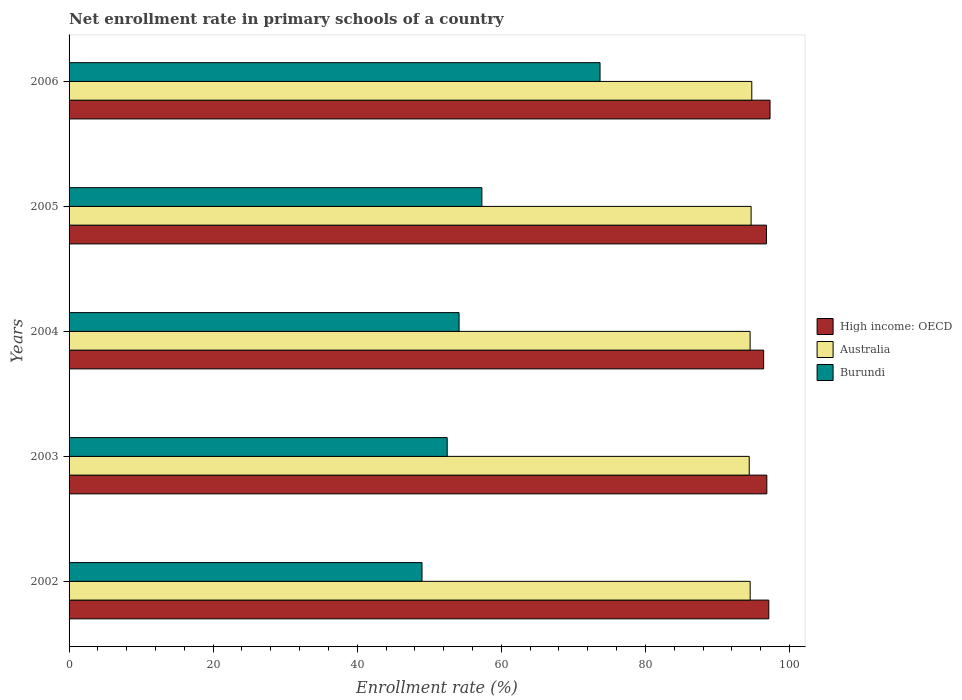How many different coloured bars are there?
Your answer should be compact. 3. Are the number of bars per tick equal to the number of legend labels?
Provide a succinct answer. Yes. How many bars are there on the 4th tick from the top?
Keep it short and to the point. 3. How many bars are there on the 5th tick from the bottom?
Your answer should be compact. 3. What is the enrollment rate in primary schools in High income: OECD in 2006?
Offer a very short reply. 97.3. Across all years, what is the maximum enrollment rate in primary schools in Australia?
Your answer should be compact. 94.77. Across all years, what is the minimum enrollment rate in primary schools in Burundi?
Keep it short and to the point. 48.99. In which year was the enrollment rate in primary schools in Burundi maximum?
Your answer should be compact. 2006. In which year was the enrollment rate in primary schools in Australia minimum?
Your answer should be compact. 2003. What is the total enrollment rate in primary schools in Burundi in the graph?
Make the answer very short. 286.64. What is the difference between the enrollment rate in primary schools in Burundi in 2003 and that in 2004?
Offer a very short reply. -1.65. What is the difference between the enrollment rate in primary schools in Burundi in 2005 and the enrollment rate in primary schools in High income: OECD in 2003?
Your response must be concise. -39.55. What is the average enrollment rate in primary schools in Burundi per year?
Give a very brief answer. 57.33. In the year 2005, what is the difference between the enrollment rate in primary schools in Burundi and enrollment rate in primary schools in Australia?
Provide a short and direct response. -37.37. What is the ratio of the enrollment rate in primary schools in High income: OECD in 2004 to that in 2006?
Keep it short and to the point. 0.99. Is the enrollment rate in primary schools in Australia in 2002 less than that in 2006?
Offer a very short reply. Yes. What is the difference between the highest and the second highest enrollment rate in primary schools in Australia?
Ensure brevity in your answer.  0.1. What is the difference between the highest and the lowest enrollment rate in primary schools in High income: OECD?
Offer a very short reply. 0.89. Is the sum of the enrollment rate in primary schools in Australia in 2002 and 2004 greater than the maximum enrollment rate in primary schools in Burundi across all years?
Your response must be concise. Yes. What does the 1st bar from the bottom in 2006 represents?
Keep it short and to the point. High income: OECD. How many bars are there?
Your answer should be compact. 15. Are the values on the major ticks of X-axis written in scientific E-notation?
Provide a short and direct response. No. Does the graph contain any zero values?
Make the answer very short. No. Where does the legend appear in the graph?
Ensure brevity in your answer.  Center right. How are the legend labels stacked?
Give a very brief answer. Vertical. What is the title of the graph?
Ensure brevity in your answer.  Net enrollment rate in primary schools of a country. What is the label or title of the X-axis?
Provide a short and direct response. Enrollment rate (%). What is the Enrollment rate (%) in High income: OECD in 2002?
Provide a succinct answer. 97.13. What is the Enrollment rate (%) of Australia in 2002?
Offer a terse response. 94.55. What is the Enrollment rate (%) of Burundi in 2002?
Give a very brief answer. 48.99. What is the Enrollment rate (%) in High income: OECD in 2003?
Give a very brief answer. 96.86. What is the Enrollment rate (%) of Australia in 2003?
Provide a short and direct response. 94.42. What is the Enrollment rate (%) in Burundi in 2003?
Ensure brevity in your answer.  52.49. What is the Enrollment rate (%) of High income: OECD in 2004?
Your answer should be compact. 96.42. What is the Enrollment rate (%) of Australia in 2004?
Make the answer very short. 94.54. What is the Enrollment rate (%) in Burundi in 2004?
Keep it short and to the point. 54.14. What is the Enrollment rate (%) in High income: OECD in 2005?
Provide a short and direct response. 96.81. What is the Enrollment rate (%) in Australia in 2005?
Provide a short and direct response. 94.68. What is the Enrollment rate (%) of Burundi in 2005?
Give a very brief answer. 57.31. What is the Enrollment rate (%) of High income: OECD in 2006?
Your response must be concise. 97.3. What is the Enrollment rate (%) of Australia in 2006?
Keep it short and to the point. 94.77. What is the Enrollment rate (%) of Burundi in 2006?
Your answer should be very brief. 73.71. Across all years, what is the maximum Enrollment rate (%) of High income: OECD?
Give a very brief answer. 97.3. Across all years, what is the maximum Enrollment rate (%) of Australia?
Provide a short and direct response. 94.77. Across all years, what is the maximum Enrollment rate (%) of Burundi?
Keep it short and to the point. 73.71. Across all years, what is the minimum Enrollment rate (%) of High income: OECD?
Your answer should be very brief. 96.42. Across all years, what is the minimum Enrollment rate (%) in Australia?
Keep it short and to the point. 94.42. Across all years, what is the minimum Enrollment rate (%) in Burundi?
Provide a short and direct response. 48.99. What is the total Enrollment rate (%) in High income: OECD in the graph?
Make the answer very short. 484.52. What is the total Enrollment rate (%) in Australia in the graph?
Offer a very short reply. 472.95. What is the total Enrollment rate (%) in Burundi in the graph?
Offer a very short reply. 286.64. What is the difference between the Enrollment rate (%) in High income: OECD in 2002 and that in 2003?
Your answer should be very brief. 0.27. What is the difference between the Enrollment rate (%) of Australia in 2002 and that in 2003?
Ensure brevity in your answer.  0.13. What is the difference between the Enrollment rate (%) in Burundi in 2002 and that in 2003?
Offer a terse response. -3.5. What is the difference between the Enrollment rate (%) of High income: OECD in 2002 and that in 2004?
Your answer should be compact. 0.71. What is the difference between the Enrollment rate (%) in Australia in 2002 and that in 2004?
Give a very brief answer. 0.01. What is the difference between the Enrollment rate (%) in Burundi in 2002 and that in 2004?
Give a very brief answer. -5.14. What is the difference between the Enrollment rate (%) of High income: OECD in 2002 and that in 2005?
Give a very brief answer. 0.33. What is the difference between the Enrollment rate (%) in Australia in 2002 and that in 2005?
Your answer should be compact. -0.13. What is the difference between the Enrollment rate (%) in Burundi in 2002 and that in 2005?
Your answer should be compact. -8.31. What is the difference between the Enrollment rate (%) in High income: OECD in 2002 and that in 2006?
Your answer should be compact. -0.17. What is the difference between the Enrollment rate (%) of Australia in 2002 and that in 2006?
Ensure brevity in your answer.  -0.23. What is the difference between the Enrollment rate (%) of Burundi in 2002 and that in 2006?
Your answer should be very brief. -24.71. What is the difference between the Enrollment rate (%) in High income: OECD in 2003 and that in 2004?
Provide a succinct answer. 0.44. What is the difference between the Enrollment rate (%) of Australia in 2003 and that in 2004?
Your answer should be very brief. -0.12. What is the difference between the Enrollment rate (%) in Burundi in 2003 and that in 2004?
Give a very brief answer. -1.65. What is the difference between the Enrollment rate (%) in High income: OECD in 2003 and that in 2005?
Your answer should be compact. 0.05. What is the difference between the Enrollment rate (%) of Australia in 2003 and that in 2005?
Your response must be concise. -0.26. What is the difference between the Enrollment rate (%) of Burundi in 2003 and that in 2005?
Your answer should be compact. -4.82. What is the difference between the Enrollment rate (%) of High income: OECD in 2003 and that in 2006?
Your answer should be very brief. -0.45. What is the difference between the Enrollment rate (%) in Australia in 2003 and that in 2006?
Offer a terse response. -0.36. What is the difference between the Enrollment rate (%) in Burundi in 2003 and that in 2006?
Offer a very short reply. -21.22. What is the difference between the Enrollment rate (%) of High income: OECD in 2004 and that in 2005?
Make the answer very short. -0.39. What is the difference between the Enrollment rate (%) in Australia in 2004 and that in 2005?
Offer a very short reply. -0.14. What is the difference between the Enrollment rate (%) in Burundi in 2004 and that in 2005?
Provide a succinct answer. -3.17. What is the difference between the Enrollment rate (%) in High income: OECD in 2004 and that in 2006?
Offer a terse response. -0.89. What is the difference between the Enrollment rate (%) in Australia in 2004 and that in 2006?
Provide a short and direct response. -0.24. What is the difference between the Enrollment rate (%) in Burundi in 2004 and that in 2006?
Keep it short and to the point. -19.57. What is the difference between the Enrollment rate (%) of High income: OECD in 2005 and that in 2006?
Ensure brevity in your answer.  -0.5. What is the difference between the Enrollment rate (%) in Australia in 2005 and that in 2006?
Offer a very short reply. -0.1. What is the difference between the Enrollment rate (%) of Burundi in 2005 and that in 2006?
Your answer should be very brief. -16.4. What is the difference between the Enrollment rate (%) of High income: OECD in 2002 and the Enrollment rate (%) of Australia in 2003?
Ensure brevity in your answer.  2.71. What is the difference between the Enrollment rate (%) in High income: OECD in 2002 and the Enrollment rate (%) in Burundi in 2003?
Offer a very short reply. 44.64. What is the difference between the Enrollment rate (%) of Australia in 2002 and the Enrollment rate (%) of Burundi in 2003?
Offer a very short reply. 42.06. What is the difference between the Enrollment rate (%) in High income: OECD in 2002 and the Enrollment rate (%) in Australia in 2004?
Your answer should be compact. 2.6. What is the difference between the Enrollment rate (%) in High income: OECD in 2002 and the Enrollment rate (%) in Burundi in 2004?
Provide a succinct answer. 42.99. What is the difference between the Enrollment rate (%) of Australia in 2002 and the Enrollment rate (%) of Burundi in 2004?
Ensure brevity in your answer.  40.41. What is the difference between the Enrollment rate (%) in High income: OECD in 2002 and the Enrollment rate (%) in Australia in 2005?
Offer a very short reply. 2.46. What is the difference between the Enrollment rate (%) in High income: OECD in 2002 and the Enrollment rate (%) in Burundi in 2005?
Make the answer very short. 39.83. What is the difference between the Enrollment rate (%) of Australia in 2002 and the Enrollment rate (%) of Burundi in 2005?
Ensure brevity in your answer.  37.24. What is the difference between the Enrollment rate (%) in High income: OECD in 2002 and the Enrollment rate (%) in Australia in 2006?
Your response must be concise. 2.36. What is the difference between the Enrollment rate (%) of High income: OECD in 2002 and the Enrollment rate (%) of Burundi in 2006?
Provide a short and direct response. 23.43. What is the difference between the Enrollment rate (%) in Australia in 2002 and the Enrollment rate (%) in Burundi in 2006?
Your response must be concise. 20.84. What is the difference between the Enrollment rate (%) of High income: OECD in 2003 and the Enrollment rate (%) of Australia in 2004?
Offer a terse response. 2.32. What is the difference between the Enrollment rate (%) in High income: OECD in 2003 and the Enrollment rate (%) in Burundi in 2004?
Your answer should be compact. 42.72. What is the difference between the Enrollment rate (%) of Australia in 2003 and the Enrollment rate (%) of Burundi in 2004?
Ensure brevity in your answer.  40.28. What is the difference between the Enrollment rate (%) in High income: OECD in 2003 and the Enrollment rate (%) in Australia in 2005?
Offer a terse response. 2.18. What is the difference between the Enrollment rate (%) in High income: OECD in 2003 and the Enrollment rate (%) in Burundi in 2005?
Your answer should be compact. 39.55. What is the difference between the Enrollment rate (%) of Australia in 2003 and the Enrollment rate (%) of Burundi in 2005?
Provide a short and direct response. 37.11. What is the difference between the Enrollment rate (%) in High income: OECD in 2003 and the Enrollment rate (%) in Australia in 2006?
Make the answer very short. 2.09. What is the difference between the Enrollment rate (%) in High income: OECD in 2003 and the Enrollment rate (%) in Burundi in 2006?
Give a very brief answer. 23.15. What is the difference between the Enrollment rate (%) of Australia in 2003 and the Enrollment rate (%) of Burundi in 2006?
Keep it short and to the point. 20.71. What is the difference between the Enrollment rate (%) of High income: OECD in 2004 and the Enrollment rate (%) of Australia in 2005?
Ensure brevity in your answer.  1.74. What is the difference between the Enrollment rate (%) of High income: OECD in 2004 and the Enrollment rate (%) of Burundi in 2005?
Provide a succinct answer. 39.11. What is the difference between the Enrollment rate (%) of Australia in 2004 and the Enrollment rate (%) of Burundi in 2005?
Give a very brief answer. 37.23. What is the difference between the Enrollment rate (%) of High income: OECD in 2004 and the Enrollment rate (%) of Australia in 2006?
Ensure brevity in your answer.  1.65. What is the difference between the Enrollment rate (%) in High income: OECD in 2004 and the Enrollment rate (%) in Burundi in 2006?
Your answer should be compact. 22.71. What is the difference between the Enrollment rate (%) in Australia in 2004 and the Enrollment rate (%) in Burundi in 2006?
Keep it short and to the point. 20.83. What is the difference between the Enrollment rate (%) in High income: OECD in 2005 and the Enrollment rate (%) in Australia in 2006?
Your answer should be very brief. 2.03. What is the difference between the Enrollment rate (%) in High income: OECD in 2005 and the Enrollment rate (%) in Burundi in 2006?
Make the answer very short. 23.1. What is the difference between the Enrollment rate (%) of Australia in 2005 and the Enrollment rate (%) of Burundi in 2006?
Your response must be concise. 20.97. What is the average Enrollment rate (%) of High income: OECD per year?
Give a very brief answer. 96.9. What is the average Enrollment rate (%) of Australia per year?
Your answer should be very brief. 94.59. What is the average Enrollment rate (%) of Burundi per year?
Offer a terse response. 57.33. In the year 2002, what is the difference between the Enrollment rate (%) in High income: OECD and Enrollment rate (%) in Australia?
Provide a short and direct response. 2.59. In the year 2002, what is the difference between the Enrollment rate (%) in High income: OECD and Enrollment rate (%) in Burundi?
Offer a terse response. 48.14. In the year 2002, what is the difference between the Enrollment rate (%) of Australia and Enrollment rate (%) of Burundi?
Give a very brief answer. 45.55. In the year 2003, what is the difference between the Enrollment rate (%) of High income: OECD and Enrollment rate (%) of Australia?
Provide a short and direct response. 2.44. In the year 2003, what is the difference between the Enrollment rate (%) in High income: OECD and Enrollment rate (%) in Burundi?
Provide a short and direct response. 44.37. In the year 2003, what is the difference between the Enrollment rate (%) in Australia and Enrollment rate (%) in Burundi?
Offer a very short reply. 41.93. In the year 2004, what is the difference between the Enrollment rate (%) in High income: OECD and Enrollment rate (%) in Australia?
Make the answer very short. 1.88. In the year 2004, what is the difference between the Enrollment rate (%) of High income: OECD and Enrollment rate (%) of Burundi?
Offer a very short reply. 42.28. In the year 2004, what is the difference between the Enrollment rate (%) of Australia and Enrollment rate (%) of Burundi?
Your response must be concise. 40.4. In the year 2005, what is the difference between the Enrollment rate (%) in High income: OECD and Enrollment rate (%) in Australia?
Keep it short and to the point. 2.13. In the year 2005, what is the difference between the Enrollment rate (%) of High income: OECD and Enrollment rate (%) of Burundi?
Keep it short and to the point. 39.5. In the year 2005, what is the difference between the Enrollment rate (%) of Australia and Enrollment rate (%) of Burundi?
Offer a terse response. 37.37. In the year 2006, what is the difference between the Enrollment rate (%) in High income: OECD and Enrollment rate (%) in Australia?
Offer a terse response. 2.53. In the year 2006, what is the difference between the Enrollment rate (%) of High income: OECD and Enrollment rate (%) of Burundi?
Your answer should be compact. 23.6. In the year 2006, what is the difference between the Enrollment rate (%) of Australia and Enrollment rate (%) of Burundi?
Keep it short and to the point. 21.07. What is the ratio of the Enrollment rate (%) of High income: OECD in 2002 to that in 2003?
Give a very brief answer. 1. What is the ratio of the Enrollment rate (%) in Australia in 2002 to that in 2003?
Offer a terse response. 1. What is the ratio of the Enrollment rate (%) of Burundi in 2002 to that in 2003?
Offer a terse response. 0.93. What is the ratio of the Enrollment rate (%) in High income: OECD in 2002 to that in 2004?
Offer a terse response. 1.01. What is the ratio of the Enrollment rate (%) in Burundi in 2002 to that in 2004?
Provide a succinct answer. 0.91. What is the ratio of the Enrollment rate (%) in High income: OECD in 2002 to that in 2005?
Your answer should be very brief. 1. What is the ratio of the Enrollment rate (%) of Burundi in 2002 to that in 2005?
Provide a succinct answer. 0.85. What is the ratio of the Enrollment rate (%) of High income: OECD in 2002 to that in 2006?
Offer a terse response. 1. What is the ratio of the Enrollment rate (%) in Australia in 2002 to that in 2006?
Offer a terse response. 1. What is the ratio of the Enrollment rate (%) in Burundi in 2002 to that in 2006?
Provide a short and direct response. 0.66. What is the ratio of the Enrollment rate (%) in High income: OECD in 2003 to that in 2004?
Provide a succinct answer. 1. What is the ratio of the Enrollment rate (%) of Burundi in 2003 to that in 2004?
Your answer should be compact. 0.97. What is the ratio of the Enrollment rate (%) of High income: OECD in 2003 to that in 2005?
Provide a short and direct response. 1. What is the ratio of the Enrollment rate (%) of Australia in 2003 to that in 2005?
Your answer should be very brief. 1. What is the ratio of the Enrollment rate (%) in Burundi in 2003 to that in 2005?
Provide a succinct answer. 0.92. What is the ratio of the Enrollment rate (%) of Burundi in 2003 to that in 2006?
Make the answer very short. 0.71. What is the ratio of the Enrollment rate (%) of Australia in 2004 to that in 2005?
Keep it short and to the point. 1. What is the ratio of the Enrollment rate (%) in Burundi in 2004 to that in 2005?
Give a very brief answer. 0.94. What is the ratio of the Enrollment rate (%) of High income: OECD in 2004 to that in 2006?
Give a very brief answer. 0.99. What is the ratio of the Enrollment rate (%) of Burundi in 2004 to that in 2006?
Provide a succinct answer. 0.73. What is the ratio of the Enrollment rate (%) in High income: OECD in 2005 to that in 2006?
Provide a short and direct response. 0.99. What is the ratio of the Enrollment rate (%) in Burundi in 2005 to that in 2006?
Give a very brief answer. 0.78. What is the difference between the highest and the second highest Enrollment rate (%) of High income: OECD?
Offer a very short reply. 0.17. What is the difference between the highest and the second highest Enrollment rate (%) of Australia?
Your answer should be compact. 0.1. What is the difference between the highest and the second highest Enrollment rate (%) in Burundi?
Make the answer very short. 16.4. What is the difference between the highest and the lowest Enrollment rate (%) in High income: OECD?
Your answer should be very brief. 0.89. What is the difference between the highest and the lowest Enrollment rate (%) in Australia?
Keep it short and to the point. 0.36. What is the difference between the highest and the lowest Enrollment rate (%) of Burundi?
Your response must be concise. 24.71. 